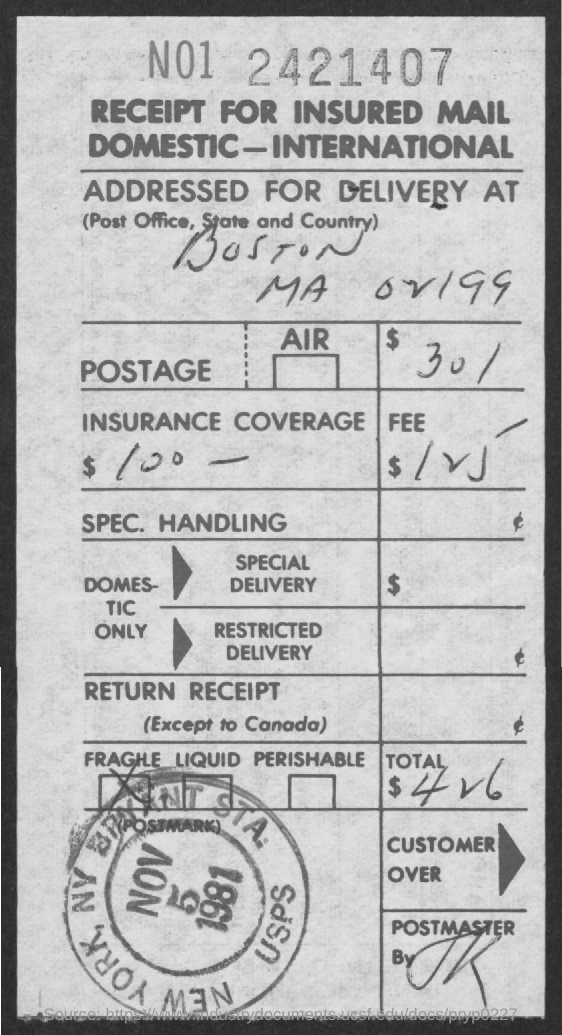Highlight a few significant elements in this photo. The insurance coverage specified is $100 -... The date on the stamp is November 5, 1981. The amount of postage is $30. 